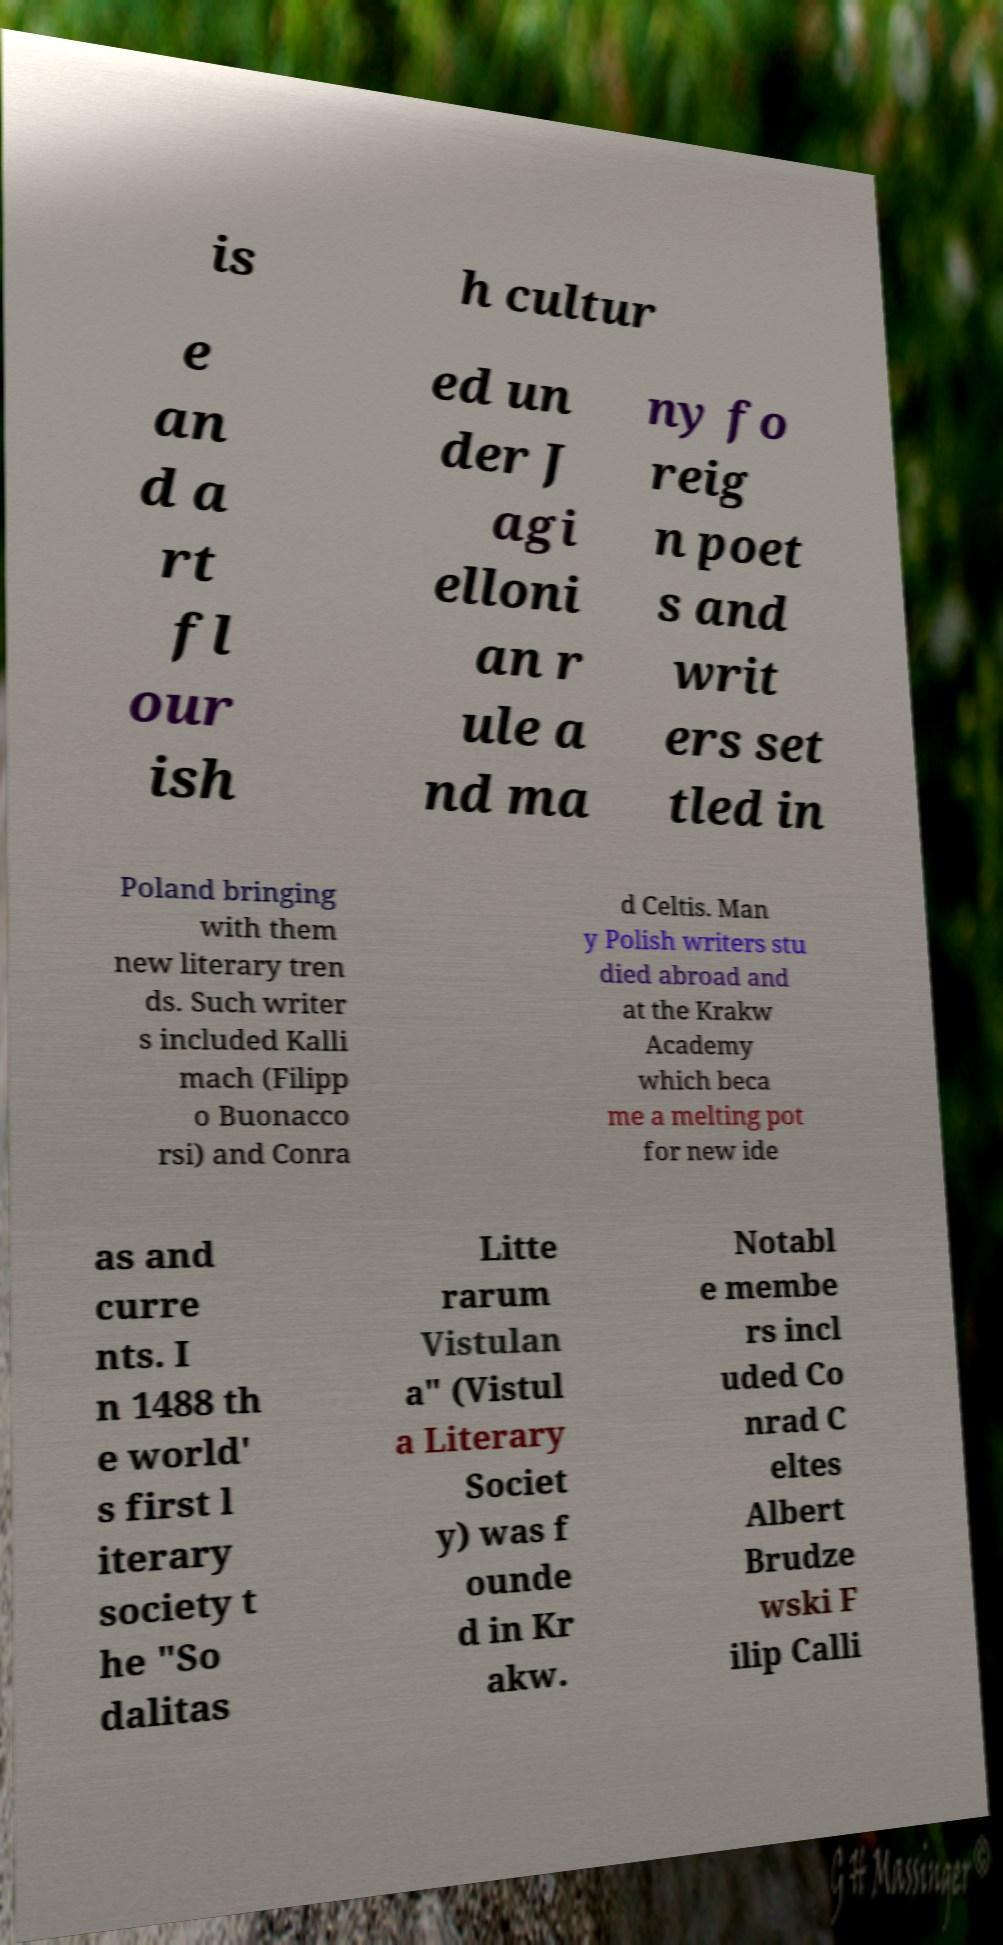Could you extract and type out the text from this image? is h cultur e an d a rt fl our ish ed un der J agi elloni an r ule a nd ma ny fo reig n poet s and writ ers set tled in Poland bringing with them new literary tren ds. Such writer s included Kalli mach (Filipp o Buonacco rsi) and Conra d Celtis. Man y Polish writers stu died abroad and at the Krakw Academy which beca me a melting pot for new ide as and curre nts. I n 1488 th e world' s first l iterary society t he "So dalitas Litte rarum Vistulan a" (Vistul a Literary Societ y) was f ounde d in Kr akw. Notabl e membe rs incl uded Co nrad C eltes Albert Brudze wski F ilip Calli 